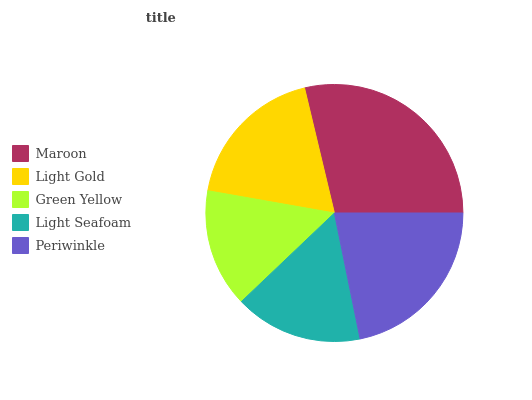Is Green Yellow the minimum?
Answer yes or no. Yes. Is Maroon the maximum?
Answer yes or no. Yes. Is Light Gold the minimum?
Answer yes or no. No. Is Light Gold the maximum?
Answer yes or no. No. Is Maroon greater than Light Gold?
Answer yes or no. Yes. Is Light Gold less than Maroon?
Answer yes or no. Yes. Is Light Gold greater than Maroon?
Answer yes or no. No. Is Maroon less than Light Gold?
Answer yes or no. No. Is Light Gold the high median?
Answer yes or no. Yes. Is Light Gold the low median?
Answer yes or no. Yes. Is Maroon the high median?
Answer yes or no. No. Is Green Yellow the low median?
Answer yes or no. No. 